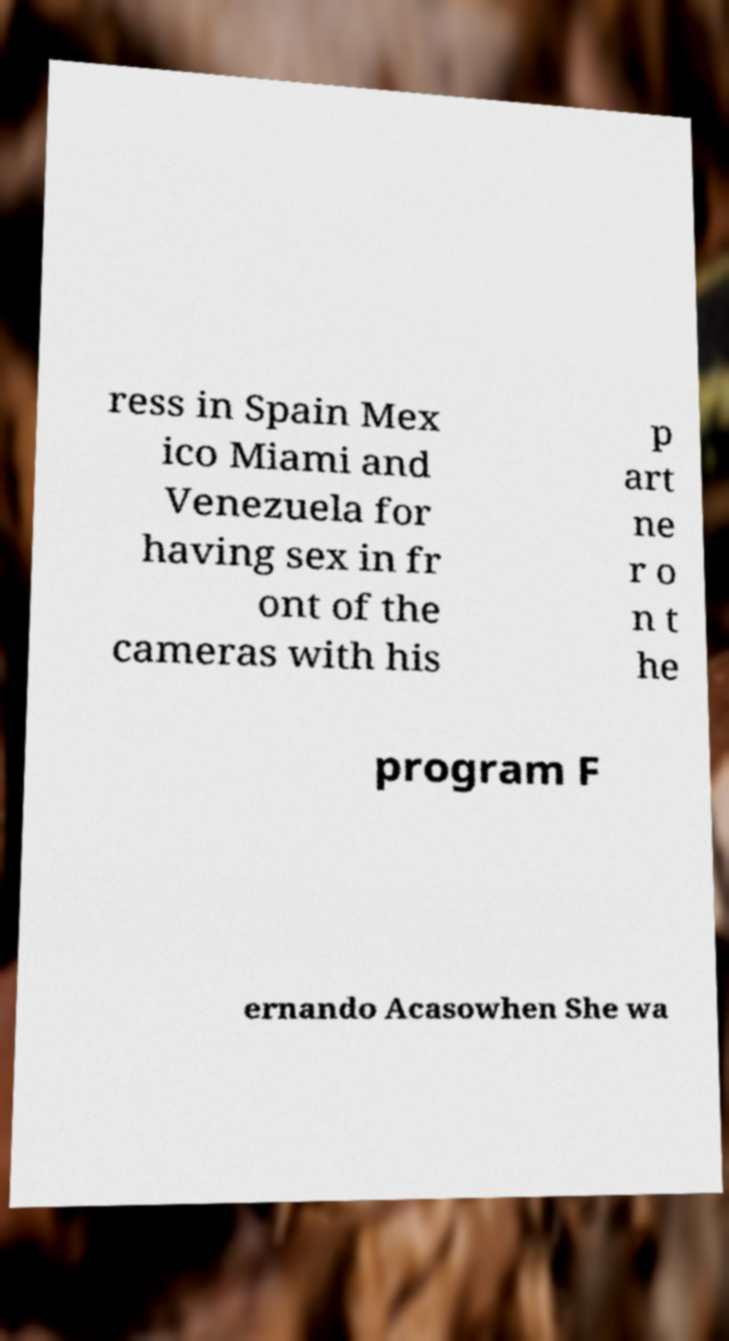What messages or text are displayed in this image? I need them in a readable, typed format. ress in Spain Mex ico Miami and Venezuela for having sex in fr ont of the cameras with his p art ne r o n t he program F ernando Acasowhen She wa 